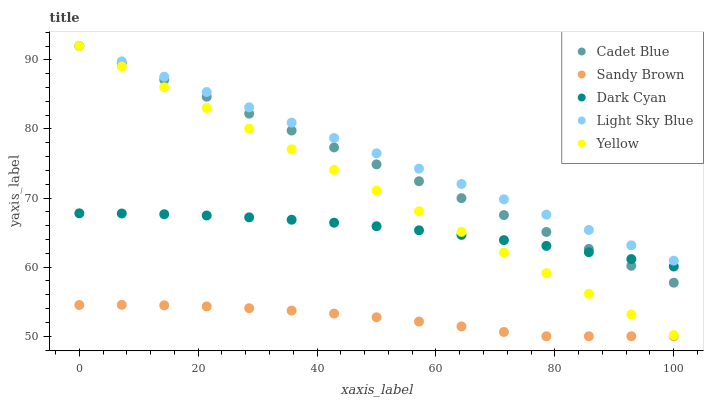Does Sandy Brown have the minimum area under the curve?
Answer yes or no. Yes. Does Light Sky Blue have the maximum area under the curve?
Answer yes or no. Yes. Does Cadet Blue have the minimum area under the curve?
Answer yes or no. No. Does Cadet Blue have the maximum area under the curve?
Answer yes or no. No. Is Light Sky Blue the smoothest?
Answer yes or no. Yes. Is Sandy Brown the roughest?
Answer yes or no. Yes. Is Cadet Blue the smoothest?
Answer yes or no. No. Is Cadet Blue the roughest?
Answer yes or no. No. Does Sandy Brown have the lowest value?
Answer yes or no. Yes. Does Cadet Blue have the lowest value?
Answer yes or no. No. Does Light Sky Blue have the highest value?
Answer yes or no. Yes. Does Sandy Brown have the highest value?
Answer yes or no. No. Is Dark Cyan less than Light Sky Blue?
Answer yes or no. Yes. Is Light Sky Blue greater than Dark Cyan?
Answer yes or no. Yes. Does Cadet Blue intersect Dark Cyan?
Answer yes or no. Yes. Is Cadet Blue less than Dark Cyan?
Answer yes or no. No. Is Cadet Blue greater than Dark Cyan?
Answer yes or no. No. Does Dark Cyan intersect Light Sky Blue?
Answer yes or no. No. 